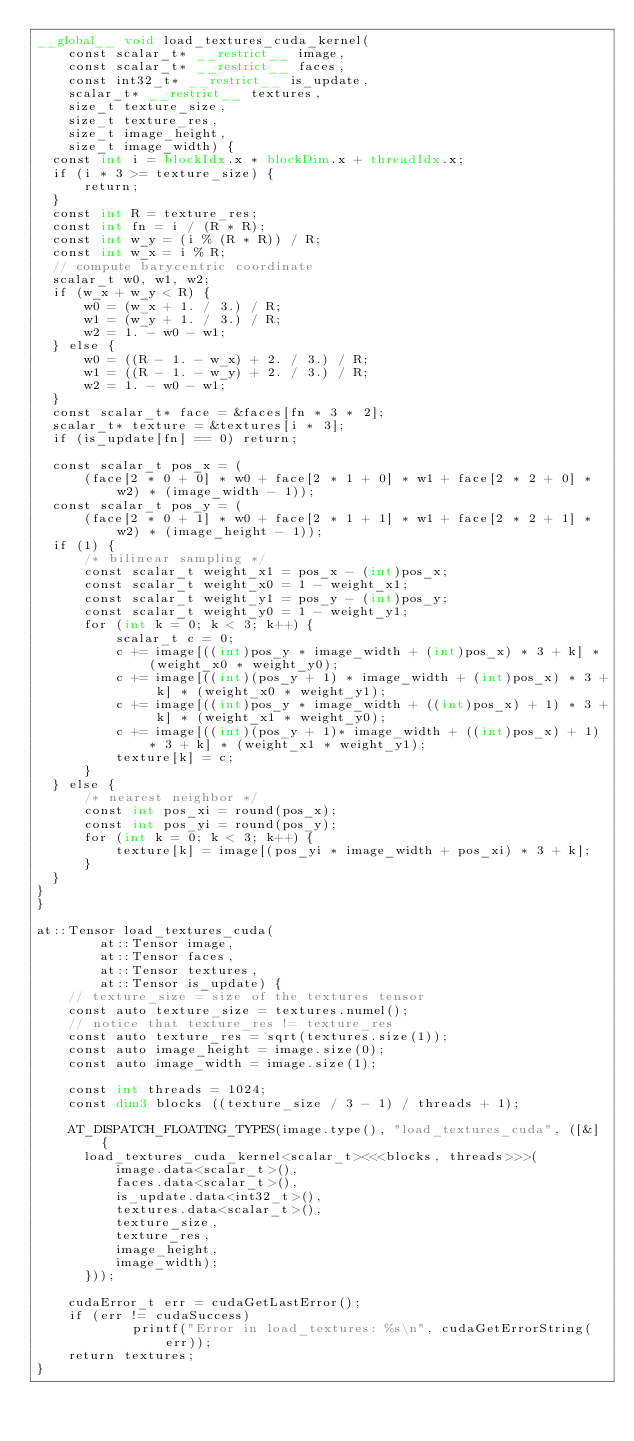<code> <loc_0><loc_0><loc_500><loc_500><_Cuda_>__global__ void load_textures_cuda_kernel(
    const scalar_t* __restrict__ image,
    const scalar_t* __restrict__ faces,
    const int32_t* __restrict__ is_update,
    scalar_t* __restrict__ textures, 
    size_t texture_size,
    size_t texture_res,
    size_t image_height,
    size_t image_width) {
  const int i = blockIdx.x * blockDim.x + threadIdx.x;
  if (i * 3 >= texture_size) {
      return;
  }
  const int R = texture_res;
  const int fn = i / (R * R);
  const int w_y = (i % (R * R)) / R;
  const int w_x = i % R;
  // compute barycentric coordinate
  scalar_t w0, w1, w2;
  if (w_x + w_y < R) {
      w0 = (w_x + 1. / 3.) / R;
      w1 = (w_y + 1. / 3.) / R;
      w2 = 1. - w0 - w1;
  } else {
      w0 = ((R - 1. - w_x) + 2. / 3.) / R;
      w1 = ((R - 1. - w_y) + 2. / 3.) / R;
      w2 = 1. - w0 - w1;
  }
  const scalar_t* face = &faces[fn * 3 * 2];
  scalar_t* texture = &textures[i * 3];
  if (is_update[fn] == 0) return;
  
  const scalar_t pos_x = (
      (face[2 * 0 + 0] * w0 + face[2 * 1 + 0] * w1 + face[2 * 2 + 0] * w2) * (image_width - 1));
  const scalar_t pos_y = (
      (face[2 * 0 + 1] * w0 + face[2 * 1 + 1] * w1 + face[2 * 2 + 1] * w2) * (image_height - 1));
  if (1) {
      /* bilinear sampling */
      const scalar_t weight_x1 = pos_x - (int)pos_x;
      const scalar_t weight_x0 = 1 - weight_x1;
      const scalar_t weight_y1 = pos_y - (int)pos_y;
      const scalar_t weight_y0 = 1 - weight_y1;
      for (int k = 0; k < 3; k++) {
          scalar_t c = 0;
          c += image[((int)pos_y * image_width + (int)pos_x) * 3 + k] * (weight_x0 * weight_y0);
          c += image[((int)(pos_y + 1) * image_width + (int)pos_x) * 3 + k] * (weight_x0 * weight_y1);
          c += image[((int)pos_y * image_width + ((int)pos_x) + 1) * 3 + k] * (weight_x1 * weight_y0);
          c += image[((int)(pos_y + 1)* image_width + ((int)pos_x) + 1) * 3 + k] * (weight_x1 * weight_y1);
          texture[k] = c;
      }
  } else {
      /* nearest neighbor */
      const int pos_xi = round(pos_x);
      const int pos_yi = round(pos_y);
      for (int k = 0; k < 3; k++) {
          texture[k] = image[(pos_yi * image_width + pos_xi) * 3 + k];
      }
  }
}
}

at::Tensor load_textures_cuda(
        at::Tensor image,
        at::Tensor faces,
        at::Tensor textures,
        at::Tensor is_update) {
    // texture_size = size of the textures tensor
    const auto texture_size = textures.numel();
    // notice that texture_res != texture_res
    const auto texture_res = sqrt(textures.size(1));
    const auto image_height = image.size(0);
    const auto image_width = image.size(1);
    
    const int threads = 1024;
    const dim3 blocks ((texture_size / 3 - 1) / threads + 1);

    AT_DISPATCH_FLOATING_TYPES(image.type(), "load_textures_cuda", ([&] {
      load_textures_cuda_kernel<scalar_t><<<blocks, threads>>>(
          image.data<scalar_t>(),
          faces.data<scalar_t>(),
          is_update.data<int32_t>(),
          textures.data<scalar_t>(),
          texture_size,
          texture_res,
          image_height,
          image_width);
      }));

    cudaError_t err = cudaGetLastError();
    if (err != cudaSuccess) 
            printf("Error in load_textures: %s\n", cudaGetErrorString(err));
    return textures;
}
</code> 